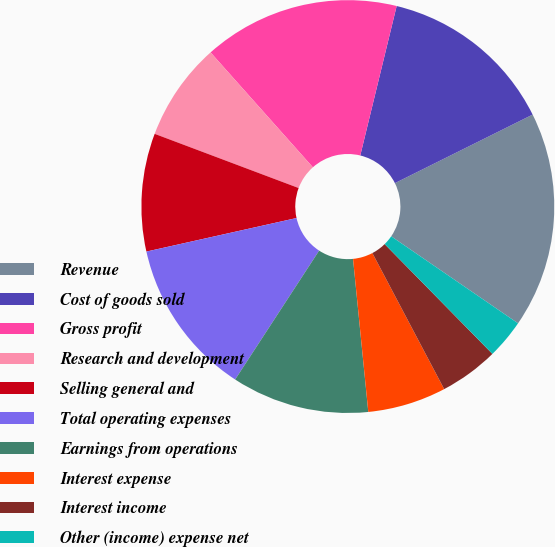<chart> <loc_0><loc_0><loc_500><loc_500><pie_chart><fcel>Revenue<fcel>Cost of goods sold<fcel>Gross profit<fcel>Research and development<fcel>Selling general and<fcel>Total operating expenses<fcel>Earnings from operations<fcel>Interest expense<fcel>Interest income<fcel>Other (income) expense net<nl><fcel>16.92%<fcel>13.85%<fcel>15.38%<fcel>7.69%<fcel>9.23%<fcel>12.31%<fcel>10.77%<fcel>6.15%<fcel>4.62%<fcel>3.08%<nl></chart> 